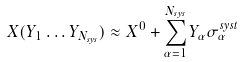Convert formula to latex. <formula><loc_0><loc_0><loc_500><loc_500>X ( Y _ { 1 } \dots Y _ { N _ { s y s } } ) \approx X ^ { 0 } + \sum _ { \alpha = 1 } ^ { N _ { s y s } } Y _ { \alpha } \sigma _ { \alpha } ^ { s y s t }</formula> 